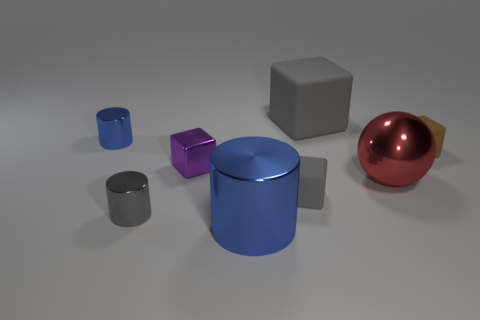Subtract all blue blocks. Subtract all red balls. How many blocks are left? 4 Add 2 tiny blue cylinders. How many objects exist? 10 Subtract all balls. How many objects are left? 7 Subtract 0 blue balls. How many objects are left? 8 Subtract all cylinders. Subtract all big blue shiny cylinders. How many objects are left? 4 Add 1 purple metallic blocks. How many purple metallic blocks are left? 2 Add 5 metallic blocks. How many metallic blocks exist? 6 